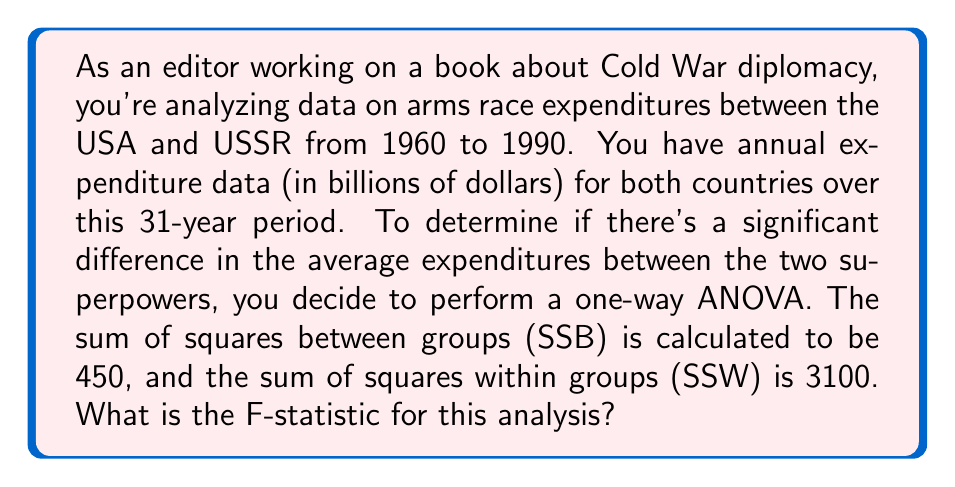Give your solution to this math problem. To calculate the F-statistic for a one-way ANOVA, we need to follow these steps:

1. Calculate the degrees of freedom:
   - Between groups: $df_B = k - 1$, where k is the number of groups (in this case, 2)
   - Within groups: $df_W = N - k$, where N is the total number of observations (31 years × 2 countries = 62)

   $df_B = 2 - 1 = 1$
   $df_W = 62 - 2 = 60$

2. Calculate the Mean Square Between (MSB) and Mean Square Within (MSW):
   $MSB = \frac{SSB}{df_B} = \frac{450}{1} = 450$
   $MSW = \frac{SSW}{df_W} = \frac{3100}{60} = 51.67$

3. Calculate the F-statistic:
   $F = \frac{MSB}{MSW} = \frac{450}{51.67} = 8.71$

The F-statistic is the ratio of the variance between groups to the variance within groups. A larger F-statistic suggests a greater likelihood of a significant difference between the groups.
Answer: $F = 8.71$ 